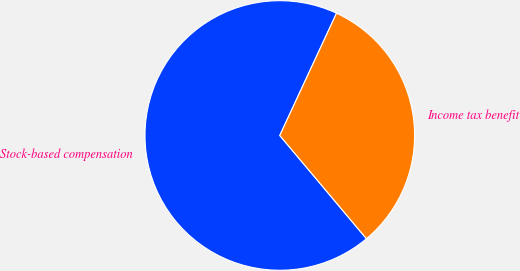Convert chart to OTSL. <chart><loc_0><loc_0><loc_500><loc_500><pie_chart><fcel>Stock-based compensation<fcel>Income tax benefit<nl><fcel>68.03%<fcel>31.97%<nl></chart> 